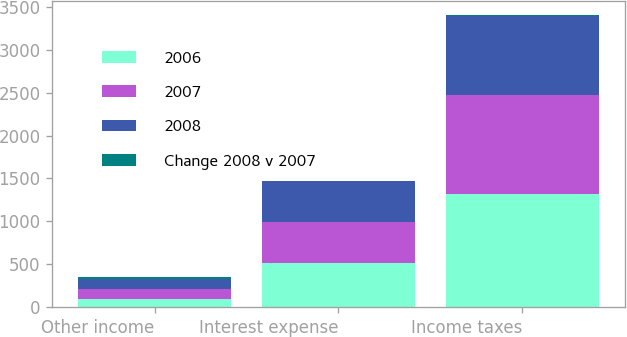Convert chart to OTSL. <chart><loc_0><loc_0><loc_500><loc_500><stacked_bar_chart><ecel><fcel>Other income<fcel>Interest expense<fcel>Income taxes<nl><fcel>2006<fcel>92<fcel>511<fcel>1318<nl><fcel>2007<fcel>116<fcel>482<fcel>1154<nl><fcel>2008<fcel>118<fcel>477<fcel>919<nl><fcel>Change 2008 v 2007<fcel>21<fcel>6<fcel>14<nl></chart> 